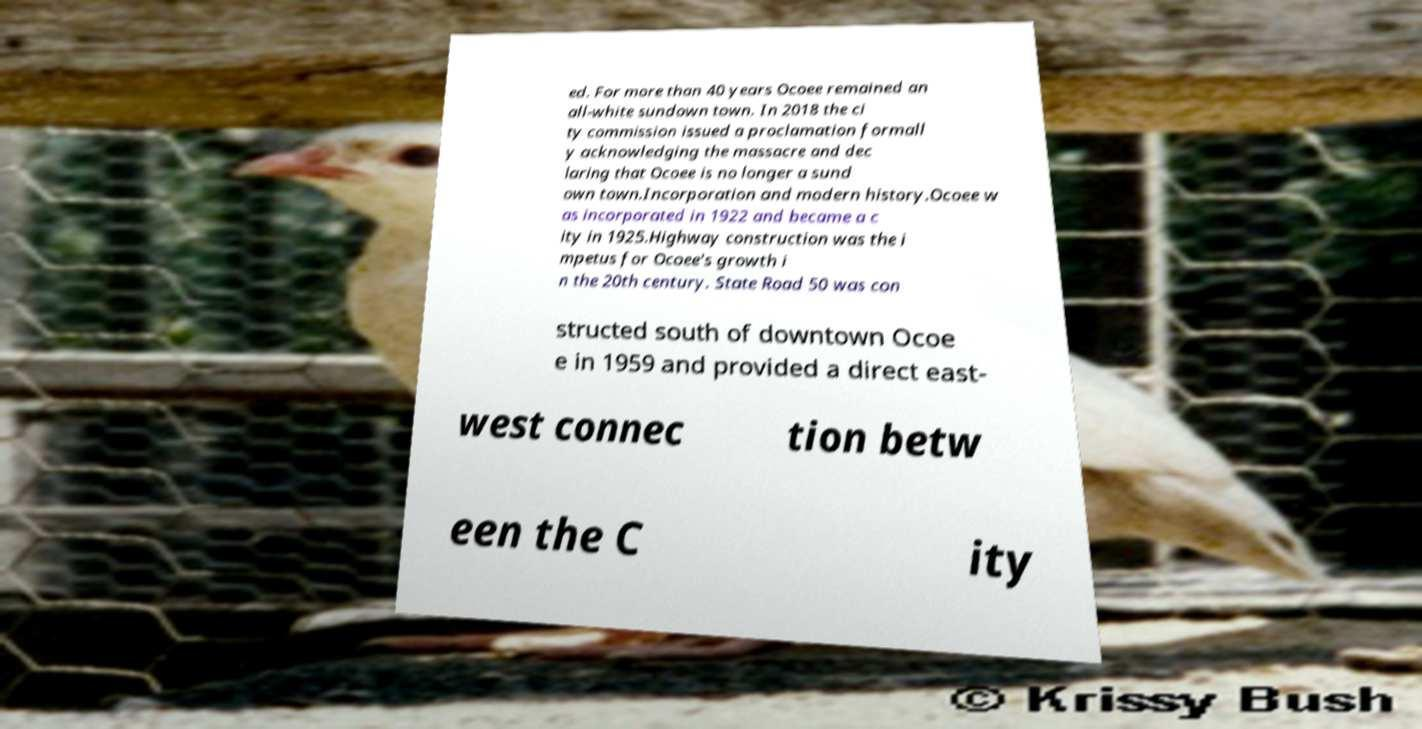Please identify and transcribe the text found in this image. ed. For more than 40 years Ocoee remained an all-white sundown town. In 2018 the ci ty commission issued a proclamation formall y acknowledging the massacre and dec laring that Ocoee is no longer a sund own town.Incorporation and modern history.Ocoee w as incorporated in 1922 and became a c ity in 1925.Highway construction was the i mpetus for Ocoee's growth i n the 20th century. State Road 50 was con structed south of downtown Ocoe e in 1959 and provided a direct east- west connec tion betw een the C ity 